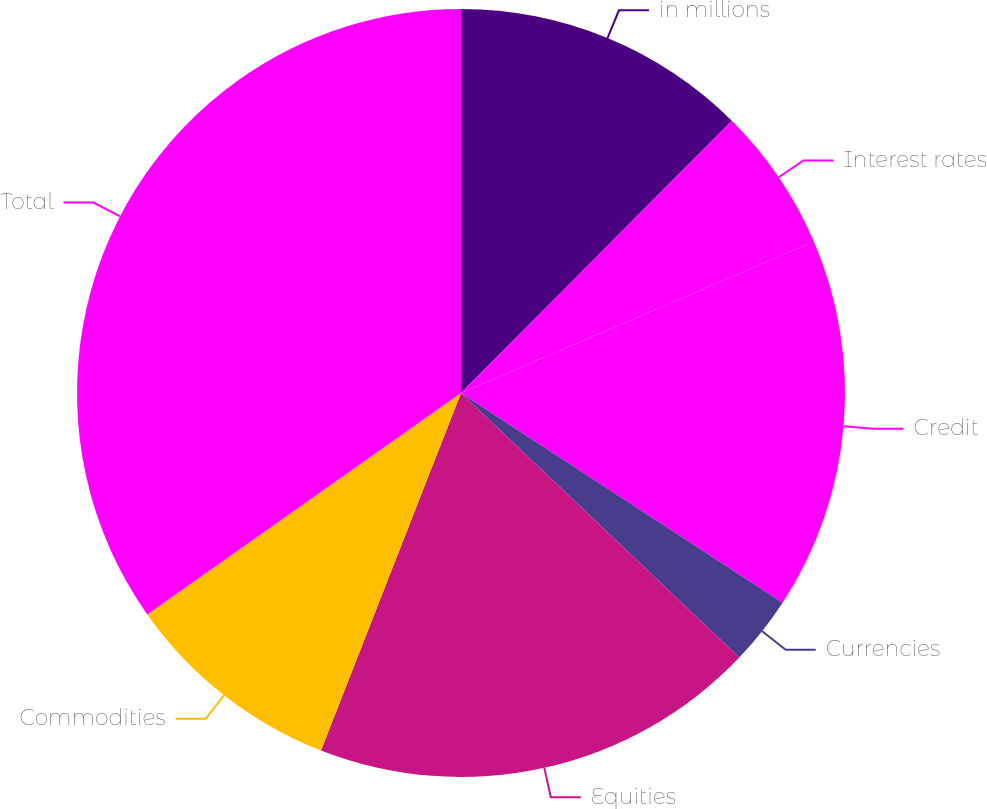Convert chart. <chart><loc_0><loc_0><loc_500><loc_500><pie_chart><fcel>in millions<fcel>Interest rates<fcel>Credit<fcel>Currencies<fcel>Equities<fcel>Commodities<fcel>Total<nl><fcel>12.46%<fcel>6.09%<fcel>15.65%<fcel>2.9%<fcel>18.84%<fcel>9.28%<fcel>34.78%<nl></chart> 